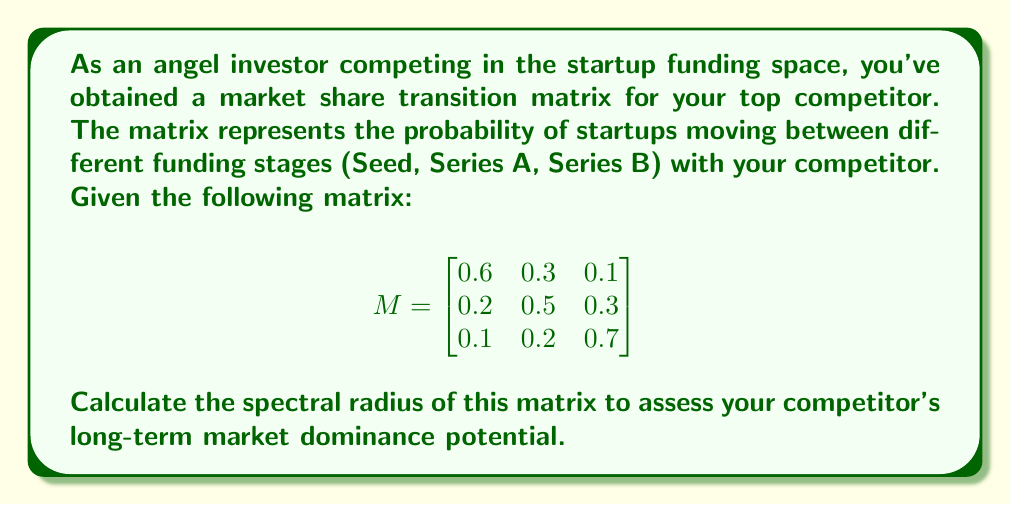Provide a solution to this math problem. To calculate the spectral radius of the matrix M, we need to follow these steps:

1) First, we need to find the characteristic polynomial of the matrix:
   $det(M - \lambda I) = 0$

2) Expanding this:
   $$
   \begin{vmatrix}
   0.6-\lambda & 0.3 & 0.1 \\
   0.2 & 0.5-\lambda & 0.3 \\
   0.1 & 0.2 & 0.7-\lambda
   \end{vmatrix} = 0
   $$

3) This yields the characteristic equation:
   $-\lambda^3 + 1.8\lambda^2 - 0.97\lambda + 0.158 = 0$

4) Solving this equation (using a computer algebra system or numerical methods) gives us the eigenvalues:
   $\lambda_1 \approx 1$
   $\lambda_2 \approx 0.4472$
   $\lambda_3 \approx 0.3528$

5) The spectral radius is the maximum absolute value of the eigenvalues:
   $\rho(M) = \max(|\lambda_1|, |\lambda_2|, |\lambda_3|) = |\lambda_1| \approx 1$

6) Given that the spectral radius is approximately 1, this suggests that your competitor's market share is likely to remain stable in the long term, neither growing nor shrinking significantly.
Answer: $\rho(M) \approx 1$ 